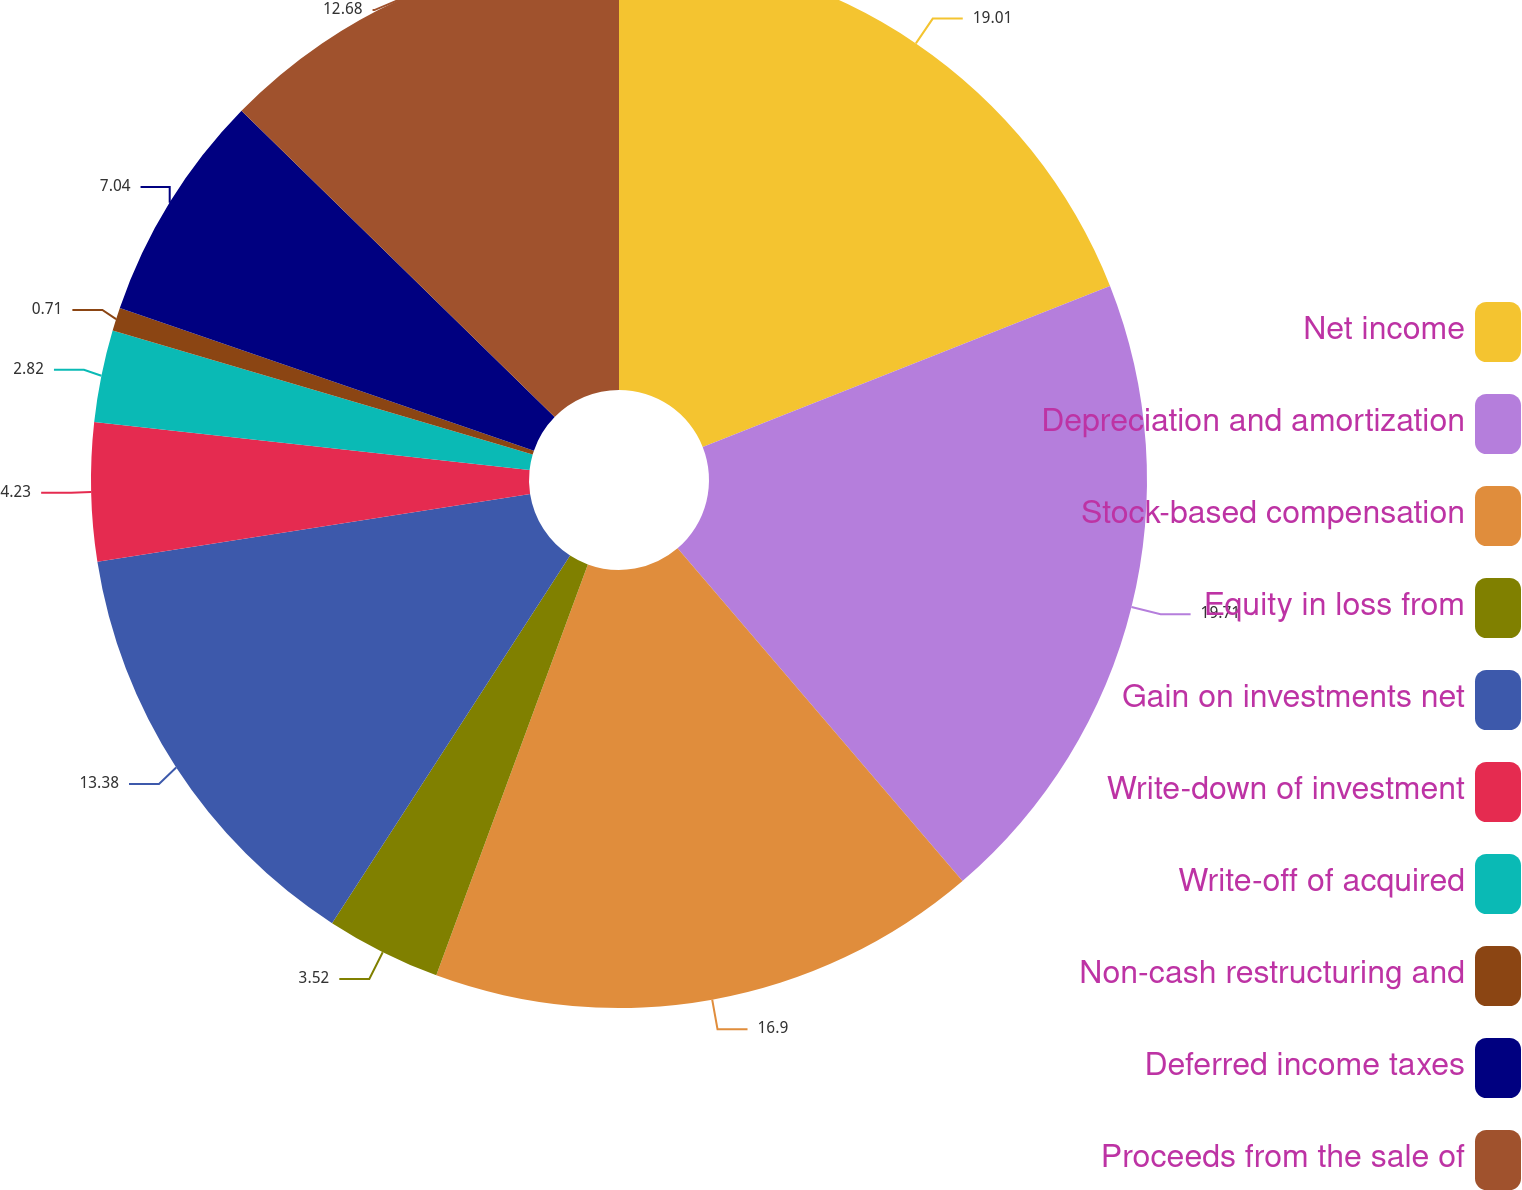Convert chart to OTSL. <chart><loc_0><loc_0><loc_500><loc_500><pie_chart><fcel>Net income<fcel>Depreciation and amortization<fcel>Stock-based compensation<fcel>Equity in loss from<fcel>Gain on investments net<fcel>Write-down of investment<fcel>Write-off of acquired<fcel>Non-cash restructuring and<fcel>Deferred income taxes<fcel>Proceeds from the sale of<nl><fcel>19.01%<fcel>19.72%<fcel>16.9%<fcel>3.52%<fcel>13.38%<fcel>4.23%<fcel>2.82%<fcel>0.71%<fcel>7.04%<fcel>12.68%<nl></chart> 